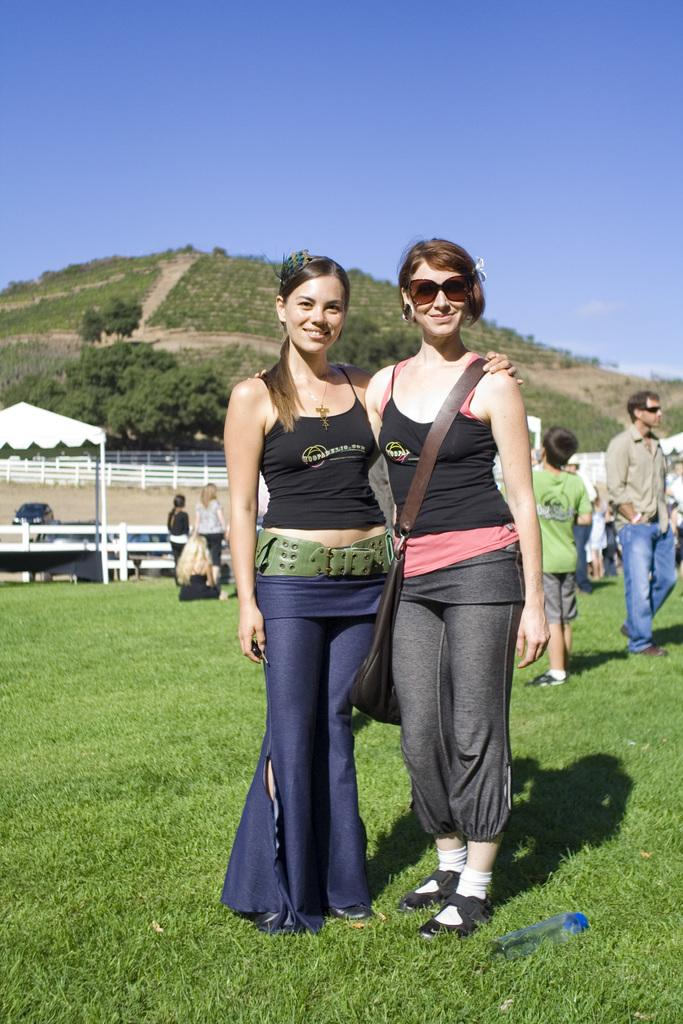How many women are present in the image? There are two women standing in the image. What can be seen in the background of the image? There are other people, trees, mountains, and a clear sky visible in the background of the image. Where is the basket of fruit located in the image? There is no basket of fruit present in the image. 